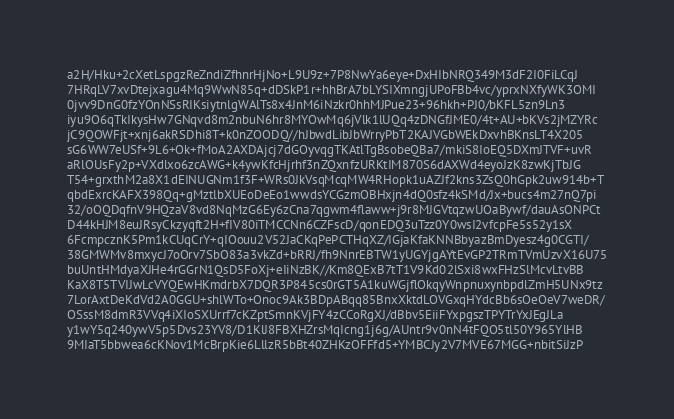Convert code to text. <code><loc_0><loc_0><loc_500><loc_500><_PHP_>a2H/Hku+2cXetLspgzReZndiZfhnrHjNo+L9U9z+7P8NwYa6eye+DxHIbNRQ349M3dF2I0FiLCqJ
7HRqLV7xvDtejxagu4Mq9WwN85q+dDSkP1r+hhBrA7bLYSIXmngjUPoFBb4vc/yprxNXfyWK3OMI
0jvv9DnG0fzYOnNSsRIKsiytnlgWAlTs8x4JnM6iNzkr0hhMJPue23+96hkh+PJ0/bKFL5zn9Ln3
iyu9O6qTkIkysHw7GNqvd8m2nbuN6hr8MYOwMq6jVlk1lUQq4zDNGfJME0/4t+AU+bKVs2jMZYRc
jC9QOWFjt+xnj6akRSDhi8T+k0nZOODQ//hJbwdLibJbWrryPbT2KAJVGbWEkDxvhBKnsLT4X205
sG6WW7eUSf+9L6+Ok+fMoA2AXDAjcj7dGOyvqgTKAtlTgBsobeQBa7/mkiS8IoEQ5DXmJTVF+uvR
aRlOUsFy2p+VXdlxo6zcAWG+k4ywKfcHjrhf3nZQxnfzURKtIM870S6dAXWd4eyoJzK8zwKjTbJG
T54+grxthM2a8X1dEINUGNm1f3F+WRs0JkVsqMcqMW4RHopk1uAZJf2kns3ZsQ0hGpk2uw914b+T
qbdExrcKAFX398Qq+gMztlbXUEoDeEo1wwdsYCGzmOBHxjn4dQ0sfz4kSMd/Jx+bucs4m27nQ7pi
32/oOQDqfnV9HQzaV8vd8NqMzG6Ey6zCna7qgwm4flaww+j9r8MJGVtqzwUOaBywf/dauAsONPCt
D44kHJM8euJRsyCkzyqft2H+fIV80iTMCCNn6CZFscD/qonEDQ3uTzz0Y0wsI2vfcpFe5s52y1sX
6FcmpcznK5Pm1kCUqCrY+qIOouu2V52JaCKqPePCTHqXZ/IGjaKfaKNNBbyazBmDyesz4g0CGTI/
38GMWMv8mxycJ7oOrv7SbO83a3vkZd+bRRJ/fh9NnrEBTW1yUGYjgAYtEvGP2TRmTVmUzvX16U75
buUntHMdyaXJHe4rGGrN1QsD5FoXj+eIiNzBK//Km8QExB7tT1V9Kd02lSxi8wxFHzSlMcvLtvBB
KaX8T5TVIJwLcVYQEwHKmdrbX7DQR3P845cs0rGT5A1kuWGjflOkqyWnpnuxynbpdlZmH5UNx9tz
7LorAxtDeKdVd2A0GGU+shlWTo+Onoc9Ak3BDpABqq85BnxXktdLOVGxqHYdcBb6sOeOeV7weDR/
OSssM8dmR3VVq4iXIoSXUrrf7cKZptSmnKVjFY4zCCoRgXJ/dBbv5EiiFYxpgszTPYTrYxJEgJLa
y1wY5q240ywV5p5Dvs23YV8/D1KlJ8FBXHZrsMqIcng1j6g/AUntr9v0nN4tFQO5tl50Y965YlHB
9MIaT5bbwea6cKNov1McBrpKie6LllzR5bBt40ZHKzOFFfd5+YMBCJy2V7MVE67MGG+nbitSiJzP</code> 